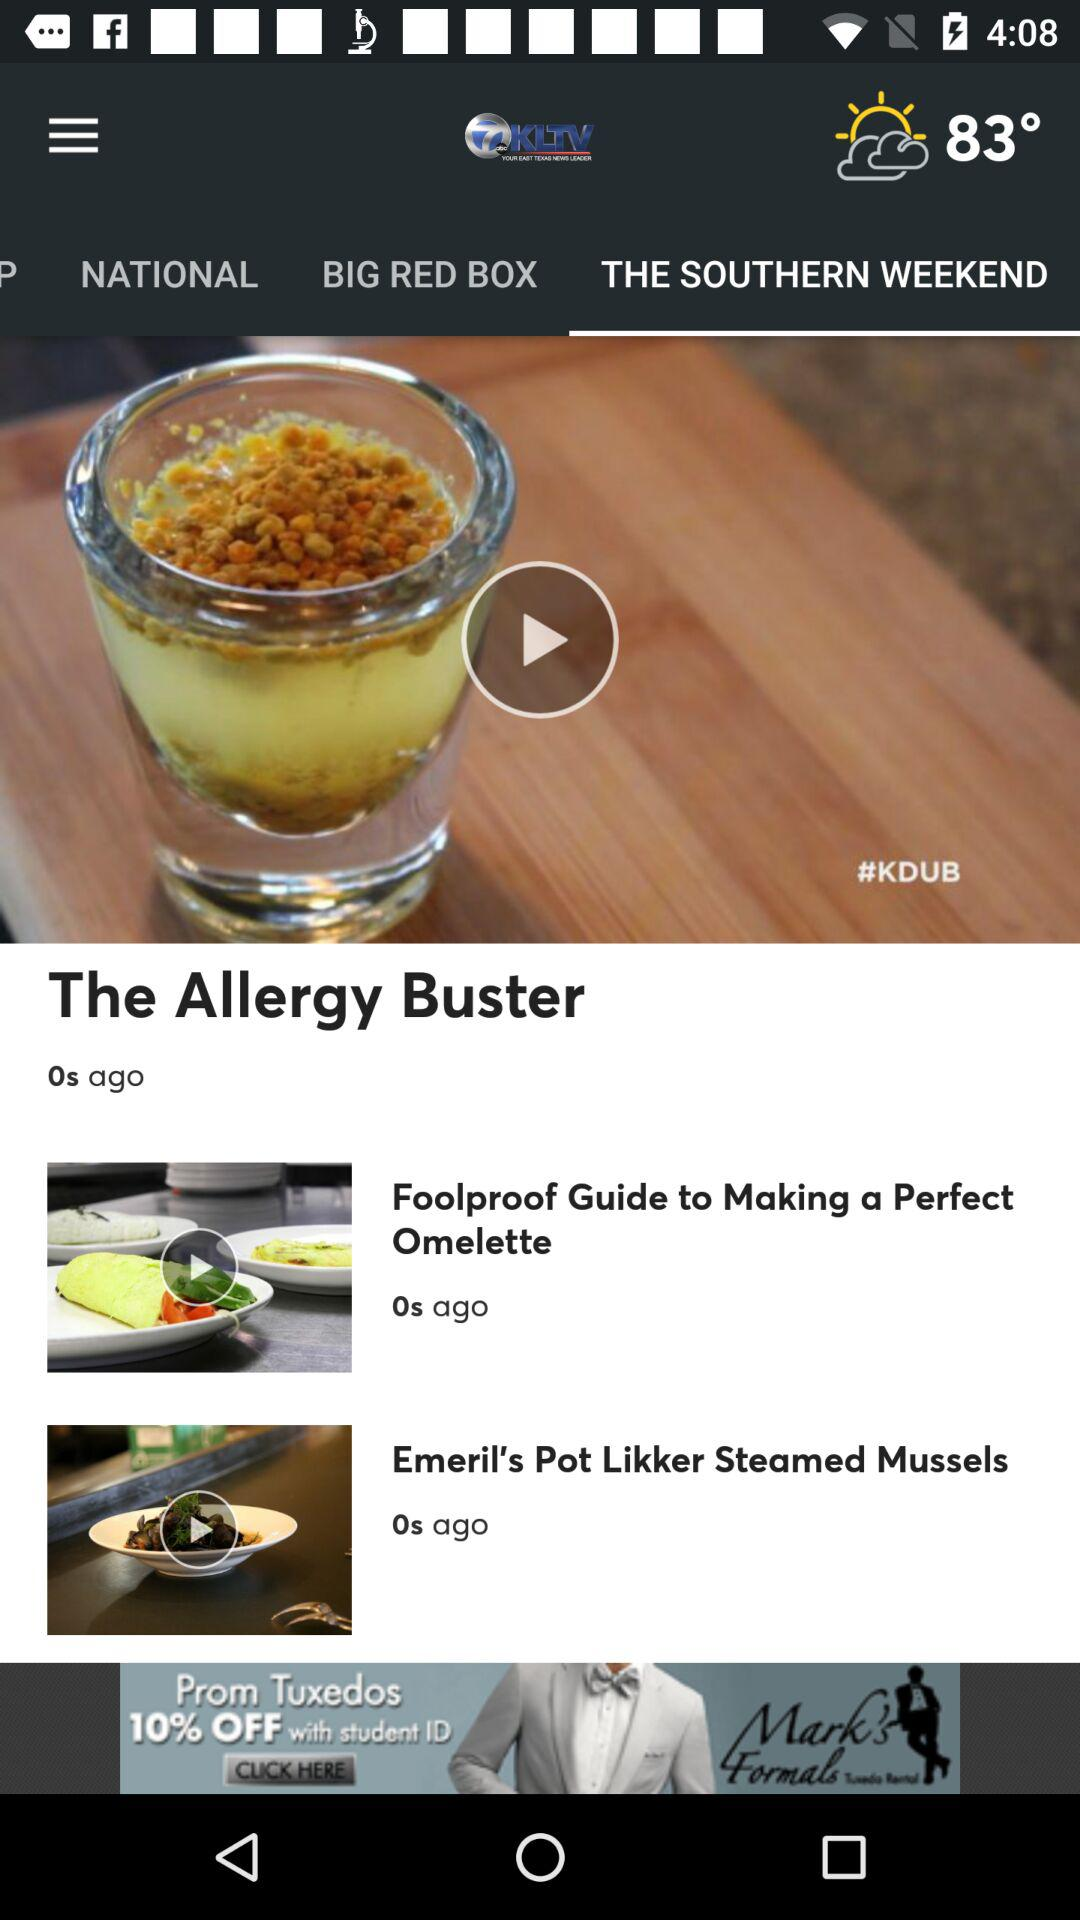Which tab is selected? The selected tab is "THE SOUTHERN WEEKEND". 